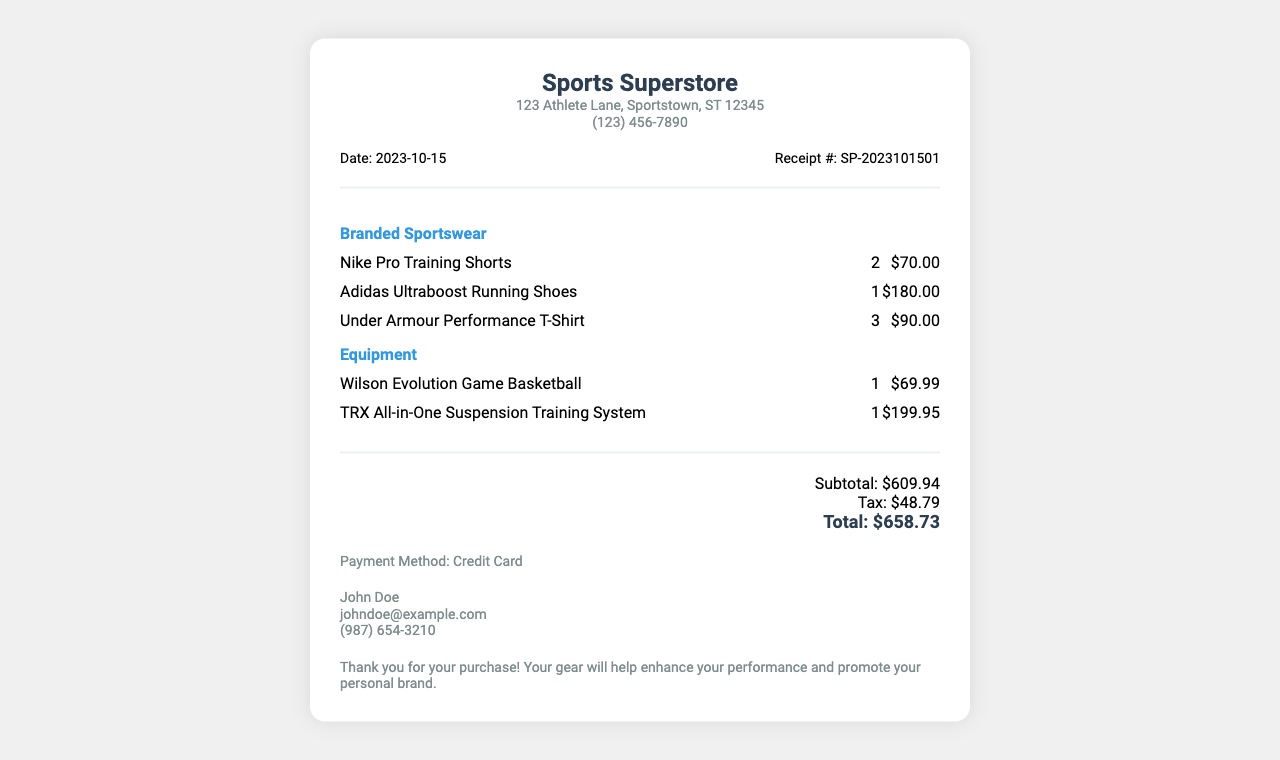What is the store name? The store name is listed at the top of the receipt.
Answer: Sports Superstore What is the date of purchase? The date of purchase is provided in the receipt details section.
Answer: 2023-10-15 How many pairs of Nike Pro Training Shorts were purchased? The quantity of Nike Pro Training Shorts is stated in the items section.
Answer: 2 What is the price of the Adidas Ultraboost Running Shoes? The price of the shoes can be found next to the item description in the receipt.
Answer: $180.00 What is the subtotal amount before tax? The subtotal is indicated in the totals section of the receipt.
Answer: $609.94 What payment method was used? The payment information section specifies the payment method.
Answer: Credit Card What is the total amount after tax? The total amount is calculated at the end of the receipt and includes tax.
Answer: $658.73 What type of items are listed in the category "Equipment"? Equipment items can be found listed in their respective category on the receipt.
Answer: Wilson Evolution Game Basketball, TRX All-in-One Suspension Training System What note is included at the bottom of the receipt? The note is provided in the notes section and expresses appreciation for the purchase.
Answer: Thank you for your purchase! Your gear will help enhance your performance and promote your personal brand 